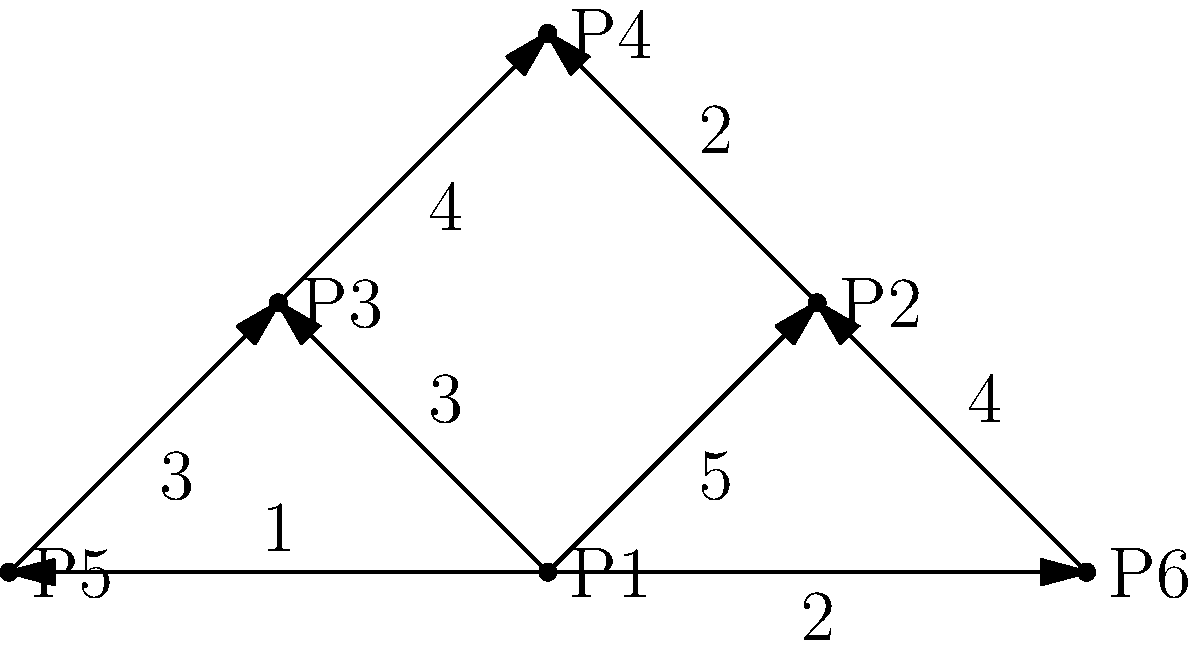In the given directed graph representing a soccer team's passing network, each vertex represents a player, and each edge represents successful passes between players, with the weight indicating the number of successful passes. Using traditional scouting methods, which player would you identify as the most crucial playmaker based on their outgoing passes? To determine the most crucial playmaker using traditional scouting methods, we need to analyze the outgoing passes for each player. Let's break it down step-by-step:

1. Identify each player's outgoing passes:
   P1: 5 to P2, 3 to P3, 1 to P5, 2 to P6 (Total: 11)
   P2: 2 to P4 (Total: 2)
   P3: 4 to P4 (Total: 4)
   P4: No outgoing passes (Total: 0)
   P5: 3 to P3 (Total: 3)
   P6: 4 to P2 (Total: 4)

2. Compare the total number of outgoing passes:
   P1: 11
   P2: 2
   P3: 4
   P4: 0
   P5: 3
   P6: 4

3. Analyze the distribution of passes:
   P1 not only has the highest total number of passes but also distributes the ball to the most teammates (4 out of 5 possible teammates).

4. Consider the strategic importance:
   P1's central position allows for distribution to both sides of the field (P2 and P3) as well as to deep-lying players (P5 and P6).

5. Evaluate the quality of passes:
   P1 has the highest single-connection weight (5 to P2), indicating a strong link with a key attacking player.

Based on traditional scouting methods, which emphasize observable patterns and on-field contributions, P1 demonstrates the most crucial playmaking role. They have the highest number of total passes, the widest distribution, and strong connections with key players in various positions.
Answer: P1 